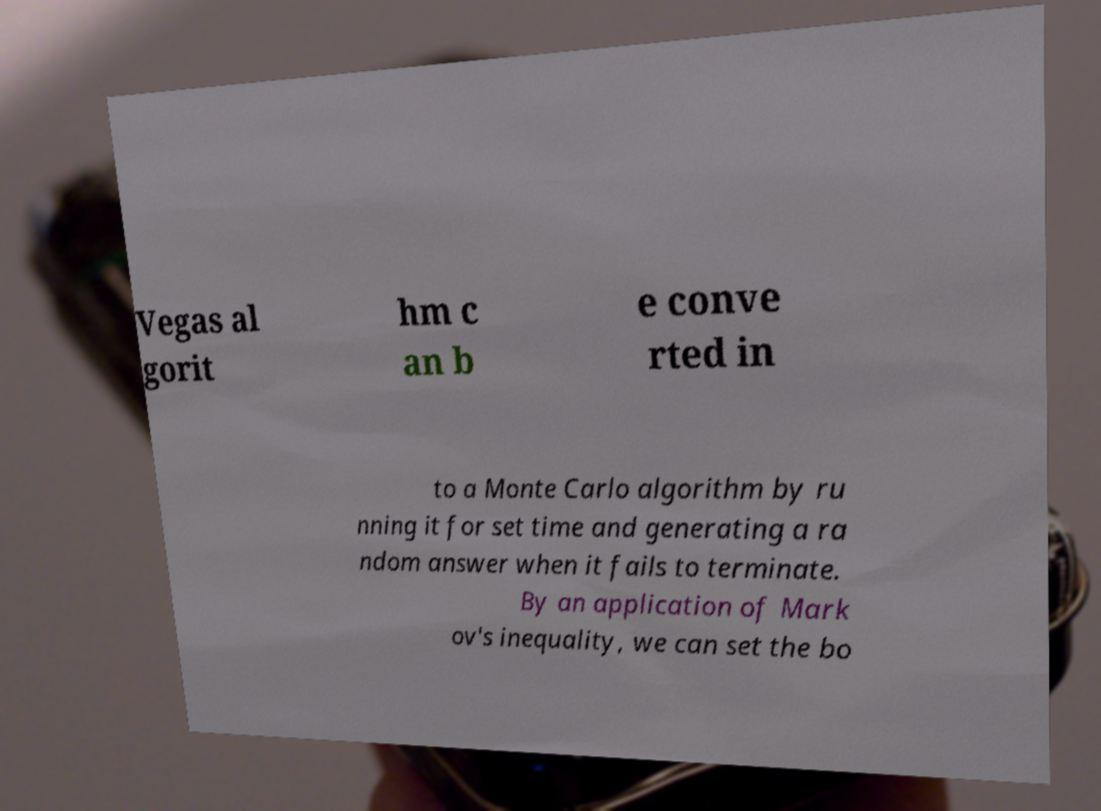Please read and relay the text visible in this image. What does it say? Vegas al gorit hm c an b e conve rted in to a Monte Carlo algorithm by ru nning it for set time and generating a ra ndom answer when it fails to terminate. By an application of Mark ov's inequality, we can set the bo 